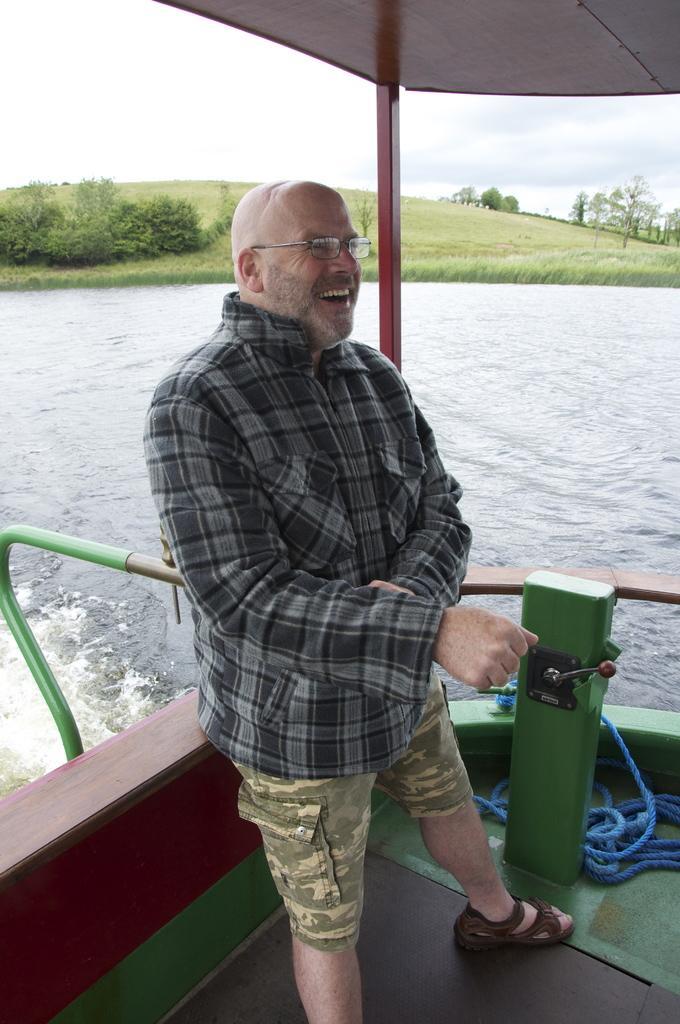Describe this image in one or two sentences. In this image in the center there is a man standing and smiling. In the background there is water, there are plants, trees and there's grass on the ground. 